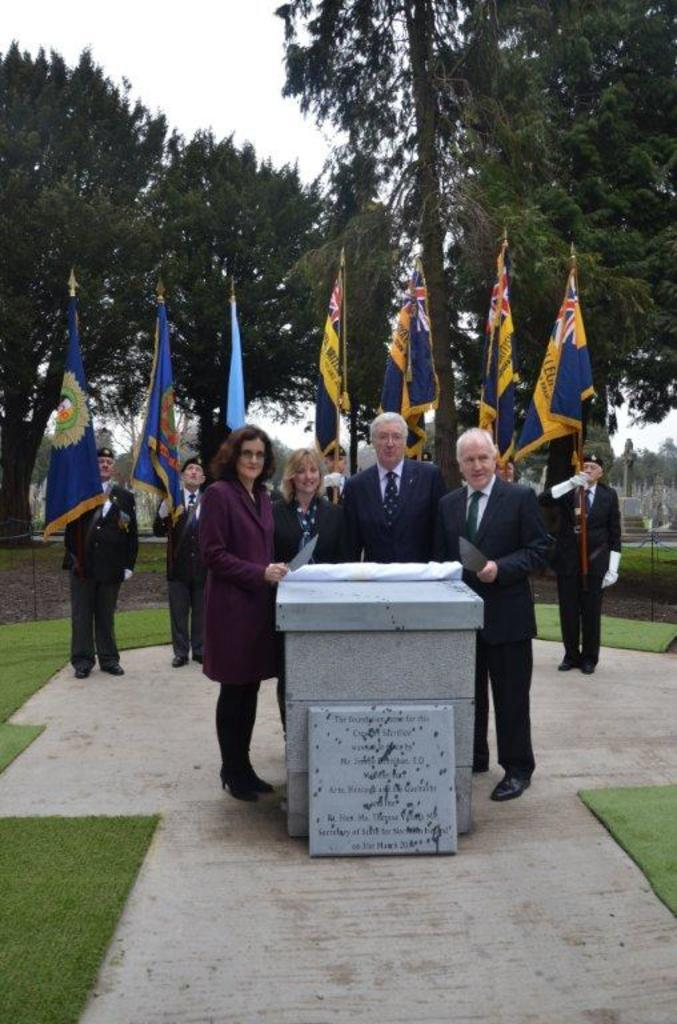What type of objects are the main subjects in the image? There are memorial stones in the image. What type of natural environment is visible in the image? There is grass visible in the image. What type of objects are also present in the image? There are flags in the image. Can you describe the people in the image? There are people in the image. What type of vegetation is visible in the image? There are trees in the image. What part of the natural environment is visible in the image? The sky is visible in the image. How many apples are hanging from the trees in the image? There are no apples visible in the image; only trees are present. What type of mass is being conducted in the image? There is no mass present in the image; it features memorial stones, grass, flags, people, and trees. 